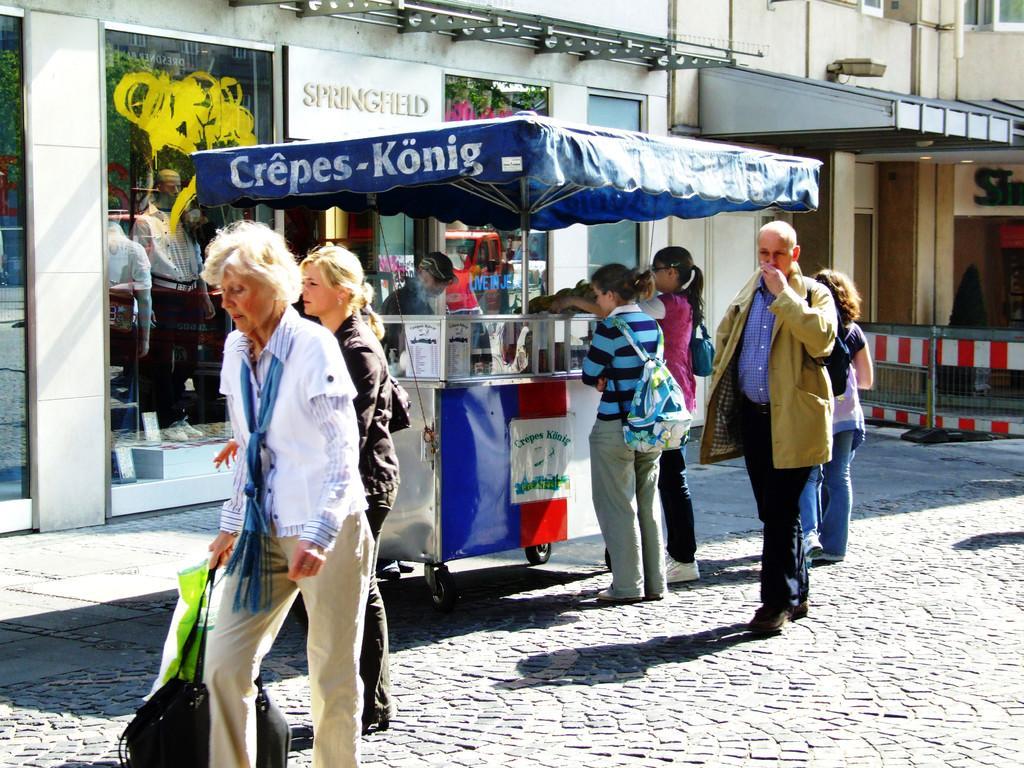In one or two sentences, can you explain what this image depicts? In the foreground of this image, there is a woman walking on the pavement holding a cover and a bag. Behind her, there are few people walking on the pavement and two people are standing near a stall. In the background, there are walls of a building and also the mannequins inside the glass of a building. 